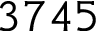Convert formula to latex. <formula><loc_0><loc_0><loc_500><loc_500>3 7 4 5</formula> 